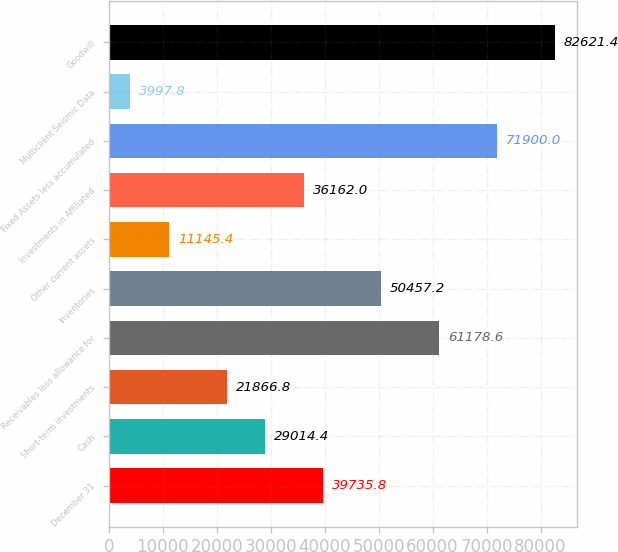Convert chart. <chart><loc_0><loc_0><loc_500><loc_500><bar_chart><fcel>December 31<fcel>Cash<fcel>Short-term investments<fcel>Receivables less allowance for<fcel>Inventories<fcel>Other current assets<fcel>Investments in Affiliated<fcel>Fixed Assets less accumulated<fcel>Multiclient Seismic Data<fcel>Goodwill<nl><fcel>39735.8<fcel>29014.4<fcel>21866.8<fcel>61178.6<fcel>50457.2<fcel>11145.4<fcel>36162<fcel>71900<fcel>3997.8<fcel>82621.4<nl></chart> 